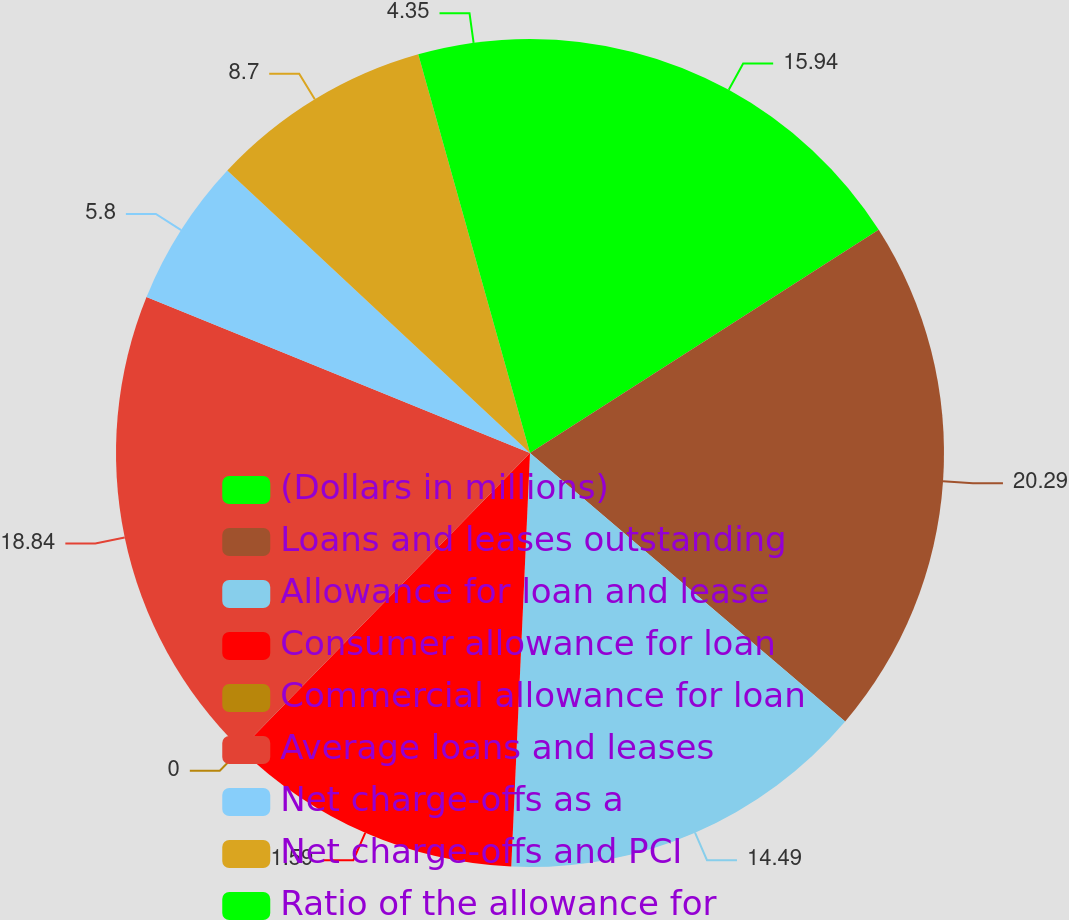Convert chart. <chart><loc_0><loc_0><loc_500><loc_500><pie_chart><fcel>(Dollars in millions)<fcel>Loans and leases outstanding<fcel>Allowance for loan and lease<fcel>Consumer allowance for loan<fcel>Commercial allowance for loan<fcel>Average loans and leases<fcel>Net charge-offs as a<fcel>Net charge-offs and PCI<fcel>Ratio of the allowance for<nl><fcel>15.94%<fcel>20.29%<fcel>14.49%<fcel>11.59%<fcel>0.0%<fcel>18.84%<fcel>5.8%<fcel>8.7%<fcel>4.35%<nl></chart> 